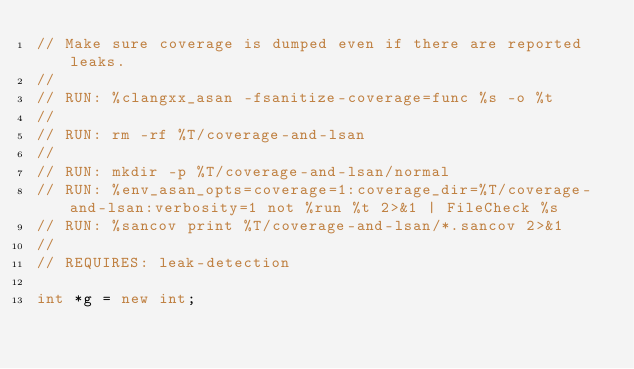<code> <loc_0><loc_0><loc_500><loc_500><_C++_>// Make sure coverage is dumped even if there are reported leaks.
//
// RUN: %clangxx_asan -fsanitize-coverage=func %s -o %t
//
// RUN: rm -rf %T/coverage-and-lsan
//
// RUN: mkdir -p %T/coverage-and-lsan/normal
// RUN: %env_asan_opts=coverage=1:coverage_dir=%T/coverage-and-lsan:verbosity=1 not %run %t 2>&1 | FileCheck %s
// RUN: %sancov print %T/coverage-and-lsan/*.sancov 2>&1
//
// REQUIRES: leak-detection

int *g = new int;</code> 